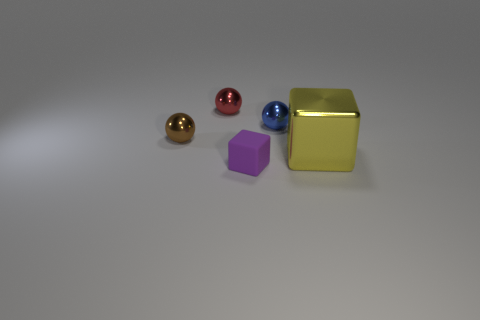What is the shape of the purple object?
Your answer should be compact. Cube. Are there more small blue shiny objects left of the red sphere than big yellow metallic things?
Give a very brief answer. No. Are there any other things that are the same shape as the tiny blue object?
Provide a succinct answer. Yes. There is another object that is the same shape as the yellow object; what color is it?
Provide a succinct answer. Purple. What is the shape of the small shiny object that is on the left side of the tiny red sphere?
Offer a very short reply. Sphere. Are there any brown things to the right of the purple block?
Your response must be concise. No. Are there any other things that are the same size as the metal block?
Provide a succinct answer. No. What color is the big object that is made of the same material as the tiny brown sphere?
Your response must be concise. Yellow. There is a block that is in front of the big object; is it the same color as the block to the right of the small blue thing?
Offer a very short reply. No. What number of balls are either small red metal objects or tiny purple objects?
Offer a terse response. 1. 